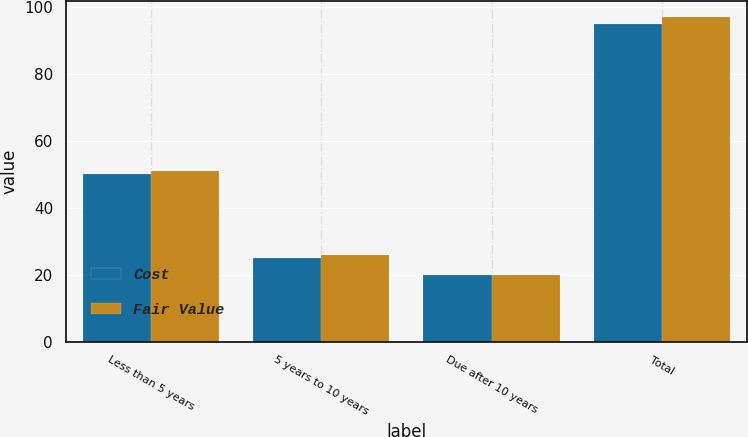Convert chart. <chart><loc_0><loc_0><loc_500><loc_500><stacked_bar_chart><ecel><fcel>Less than 5 years<fcel>5 years to 10 years<fcel>Due after 10 years<fcel>Total<nl><fcel>Cost<fcel>50<fcel>25<fcel>20<fcel>95<nl><fcel>Fair Value<fcel>51<fcel>26<fcel>20<fcel>97<nl></chart> 